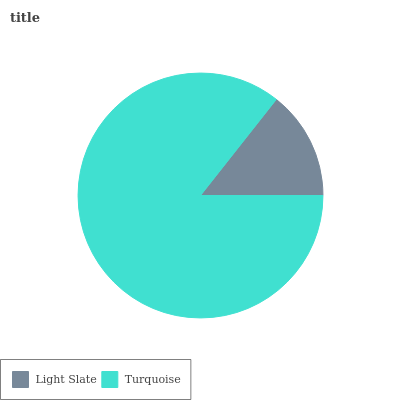Is Light Slate the minimum?
Answer yes or no. Yes. Is Turquoise the maximum?
Answer yes or no. Yes. Is Turquoise the minimum?
Answer yes or no. No. Is Turquoise greater than Light Slate?
Answer yes or no. Yes. Is Light Slate less than Turquoise?
Answer yes or no. Yes. Is Light Slate greater than Turquoise?
Answer yes or no. No. Is Turquoise less than Light Slate?
Answer yes or no. No. Is Turquoise the high median?
Answer yes or no. Yes. Is Light Slate the low median?
Answer yes or no. Yes. Is Light Slate the high median?
Answer yes or no. No. Is Turquoise the low median?
Answer yes or no. No. 